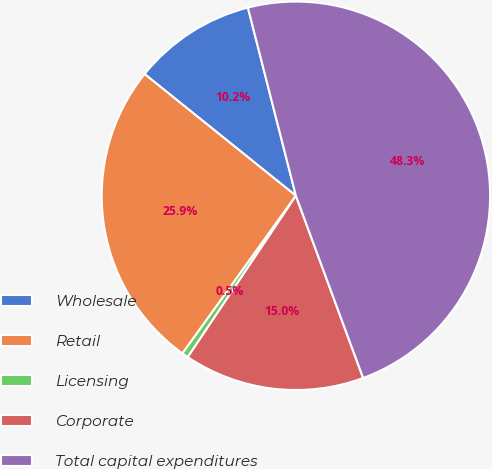<chart> <loc_0><loc_0><loc_500><loc_500><pie_chart><fcel>Wholesale<fcel>Retail<fcel>Licensing<fcel>Corporate<fcel>Total capital expenditures<nl><fcel>10.24%<fcel>25.85%<fcel>0.53%<fcel>15.02%<fcel>48.34%<nl></chart> 